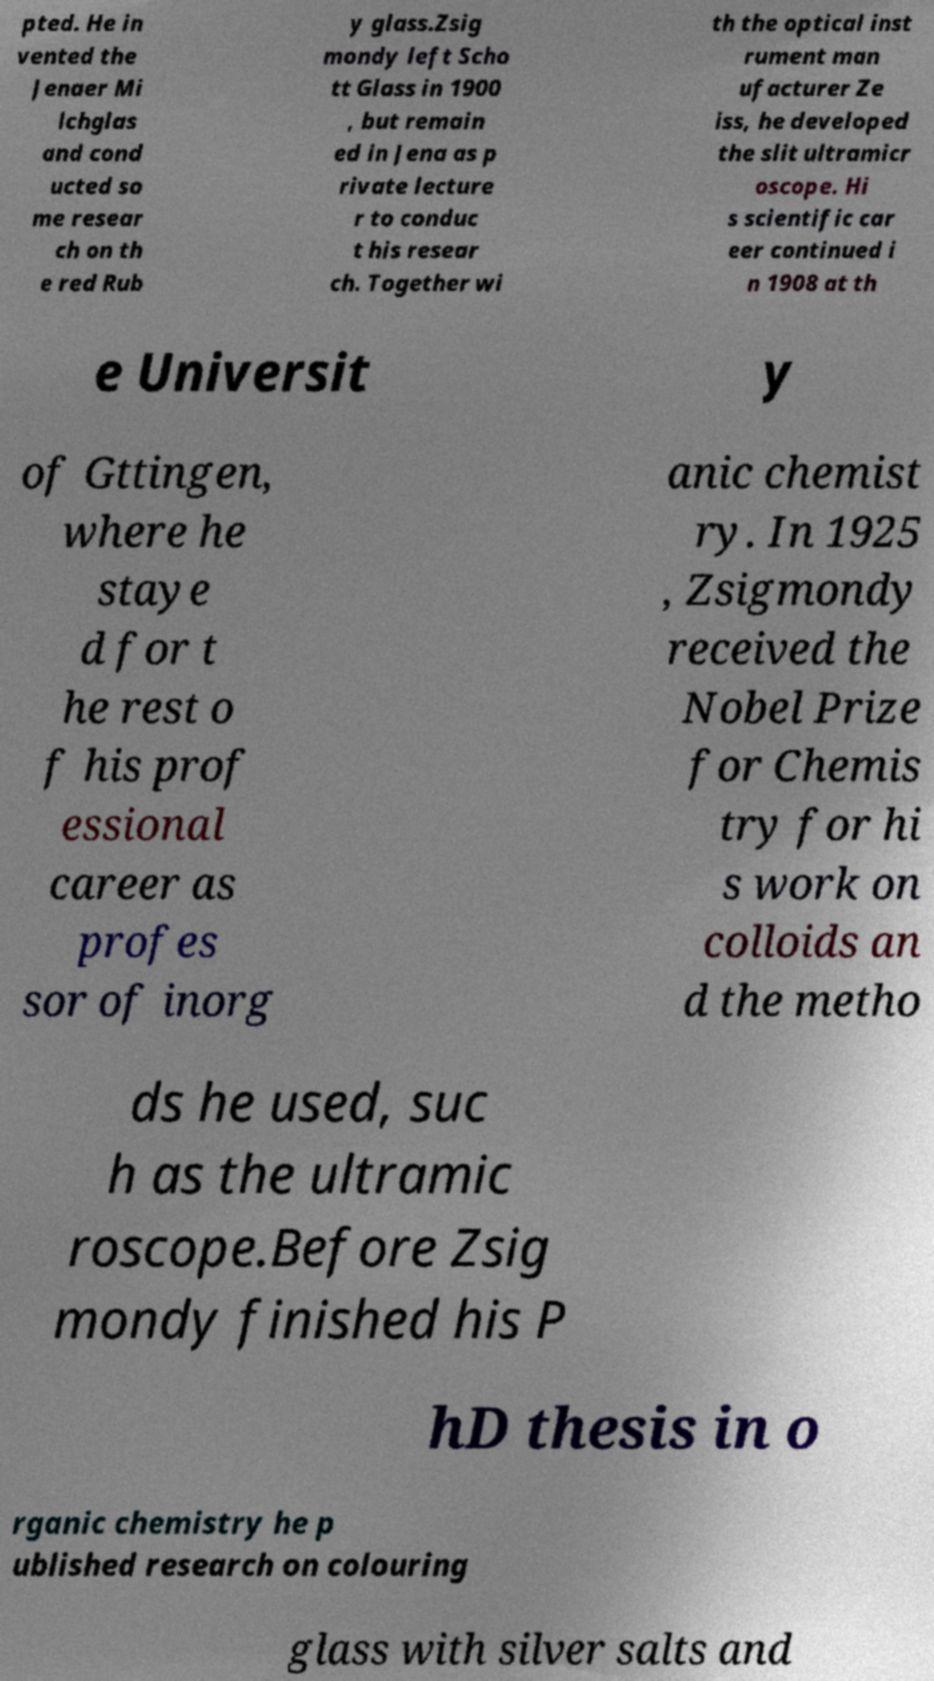For documentation purposes, I need the text within this image transcribed. Could you provide that? pted. He in vented the Jenaer Mi lchglas and cond ucted so me resear ch on th e red Rub y glass.Zsig mondy left Scho tt Glass in 1900 , but remain ed in Jena as p rivate lecture r to conduc t his resear ch. Together wi th the optical inst rument man ufacturer Ze iss, he developed the slit ultramicr oscope. Hi s scientific car eer continued i n 1908 at th e Universit y of Gttingen, where he staye d for t he rest o f his prof essional career as profes sor of inorg anic chemist ry. In 1925 , Zsigmondy received the Nobel Prize for Chemis try for hi s work on colloids an d the metho ds he used, suc h as the ultramic roscope.Before Zsig mondy finished his P hD thesis in o rganic chemistry he p ublished research on colouring glass with silver salts and 